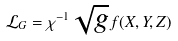Convert formula to latex. <formula><loc_0><loc_0><loc_500><loc_500>\mathcal { L } _ { G } = \chi ^ { - 1 } \sqrt { g } f ( X , Y , Z )</formula> 